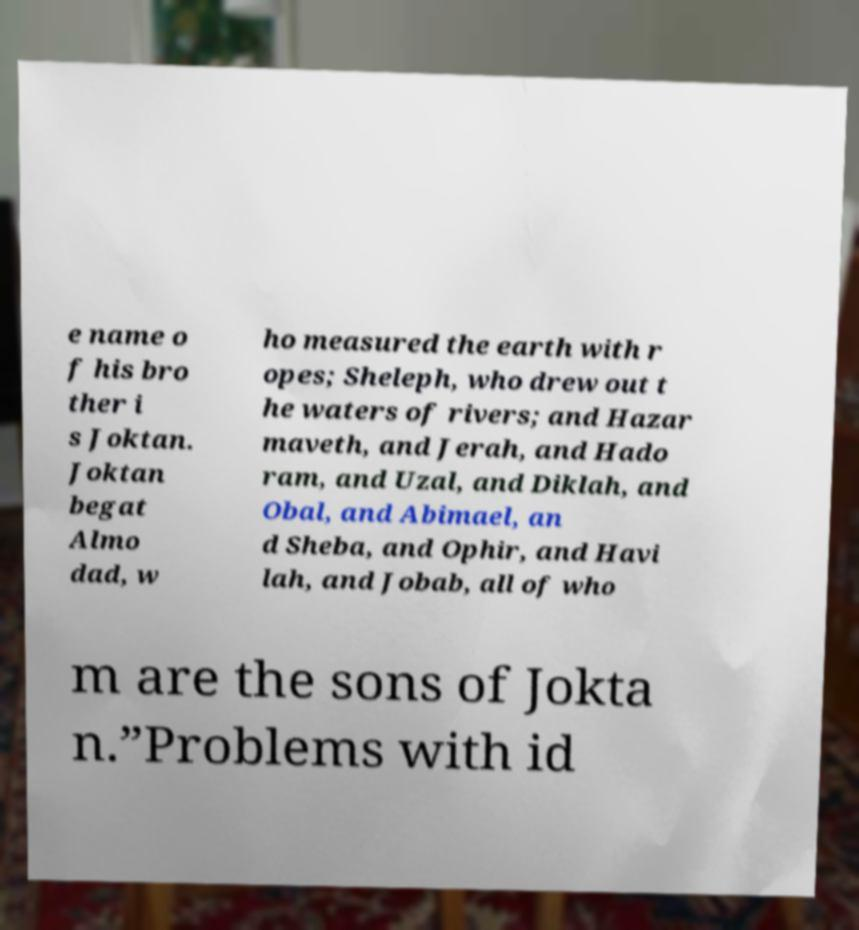Could you assist in decoding the text presented in this image and type it out clearly? e name o f his bro ther i s Joktan. Joktan begat Almo dad, w ho measured the earth with r opes; Sheleph, who drew out t he waters of rivers; and Hazar maveth, and Jerah, and Hado ram, and Uzal, and Diklah, and Obal, and Abimael, an d Sheba, and Ophir, and Havi lah, and Jobab, all of who m are the sons of Jokta n.”Problems with id 